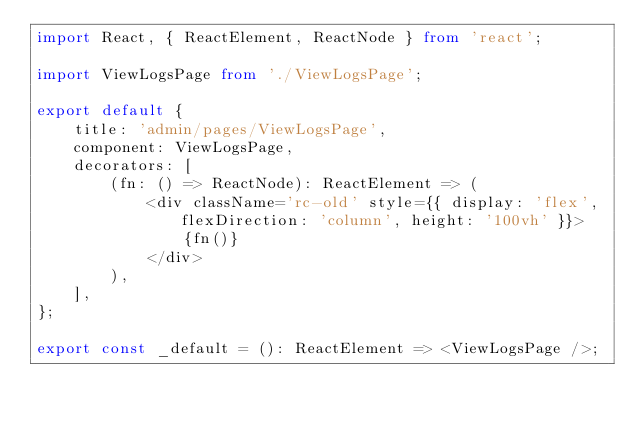Convert code to text. <code><loc_0><loc_0><loc_500><loc_500><_TypeScript_>import React, { ReactElement, ReactNode } from 'react';

import ViewLogsPage from './ViewLogsPage';

export default {
	title: 'admin/pages/ViewLogsPage',
	component: ViewLogsPage,
	decorators: [
		(fn: () => ReactNode): ReactElement => (
			<div className='rc-old' style={{ display: 'flex', flexDirection: 'column', height: '100vh' }}>
				{fn()}
			</div>
		),
	],
};

export const _default = (): ReactElement => <ViewLogsPage />;
</code> 